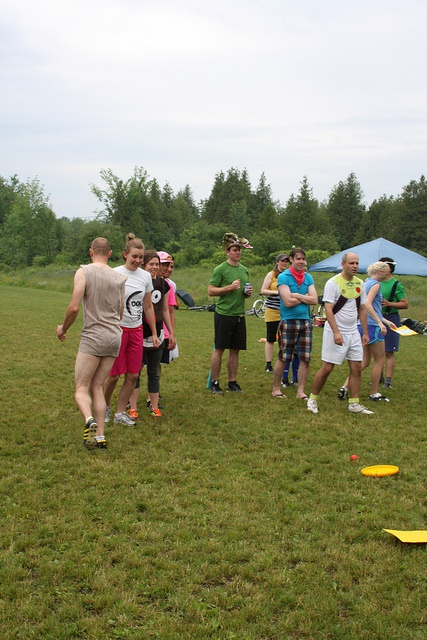Describe the objects in this image and their specific colors. I can see people in white, gray, tan, and darkgray tones, people in white, lightgray, darkgray, olive, and gray tones, people in white, brown, maroon, and lightgray tones, people in white, black, gray, and olive tones, and people in white, black, darkgreen, and green tones in this image. 